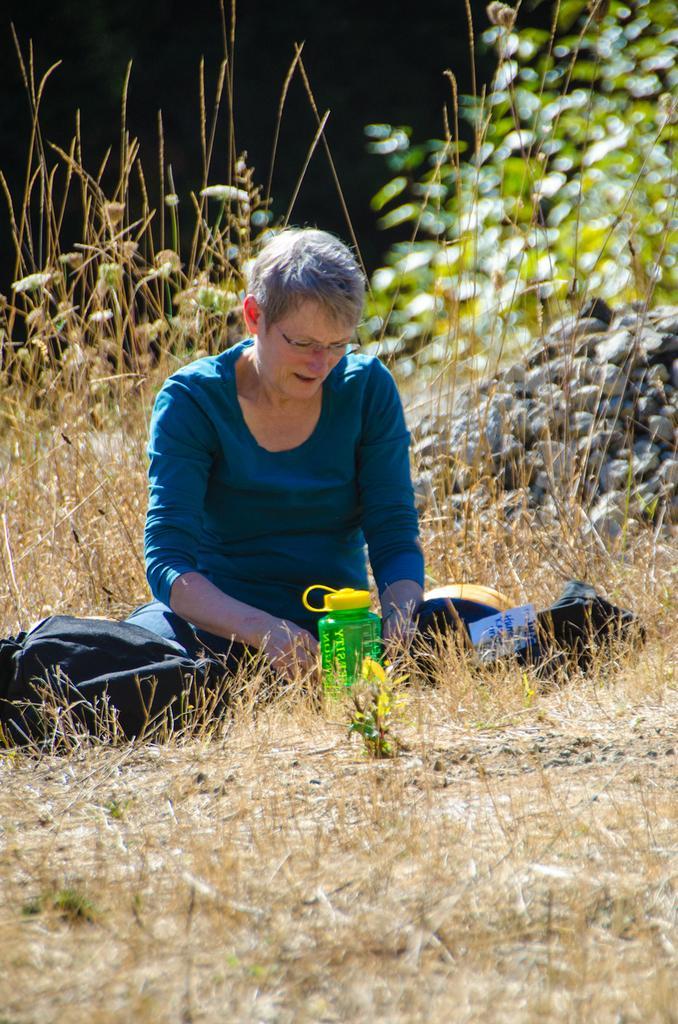How would you summarize this image in a sentence or two? This woman wore blue t-shirt, spectacles and sitting on ground. On this ground there is a bottle and bag. At background we can able to see plants and stones. 